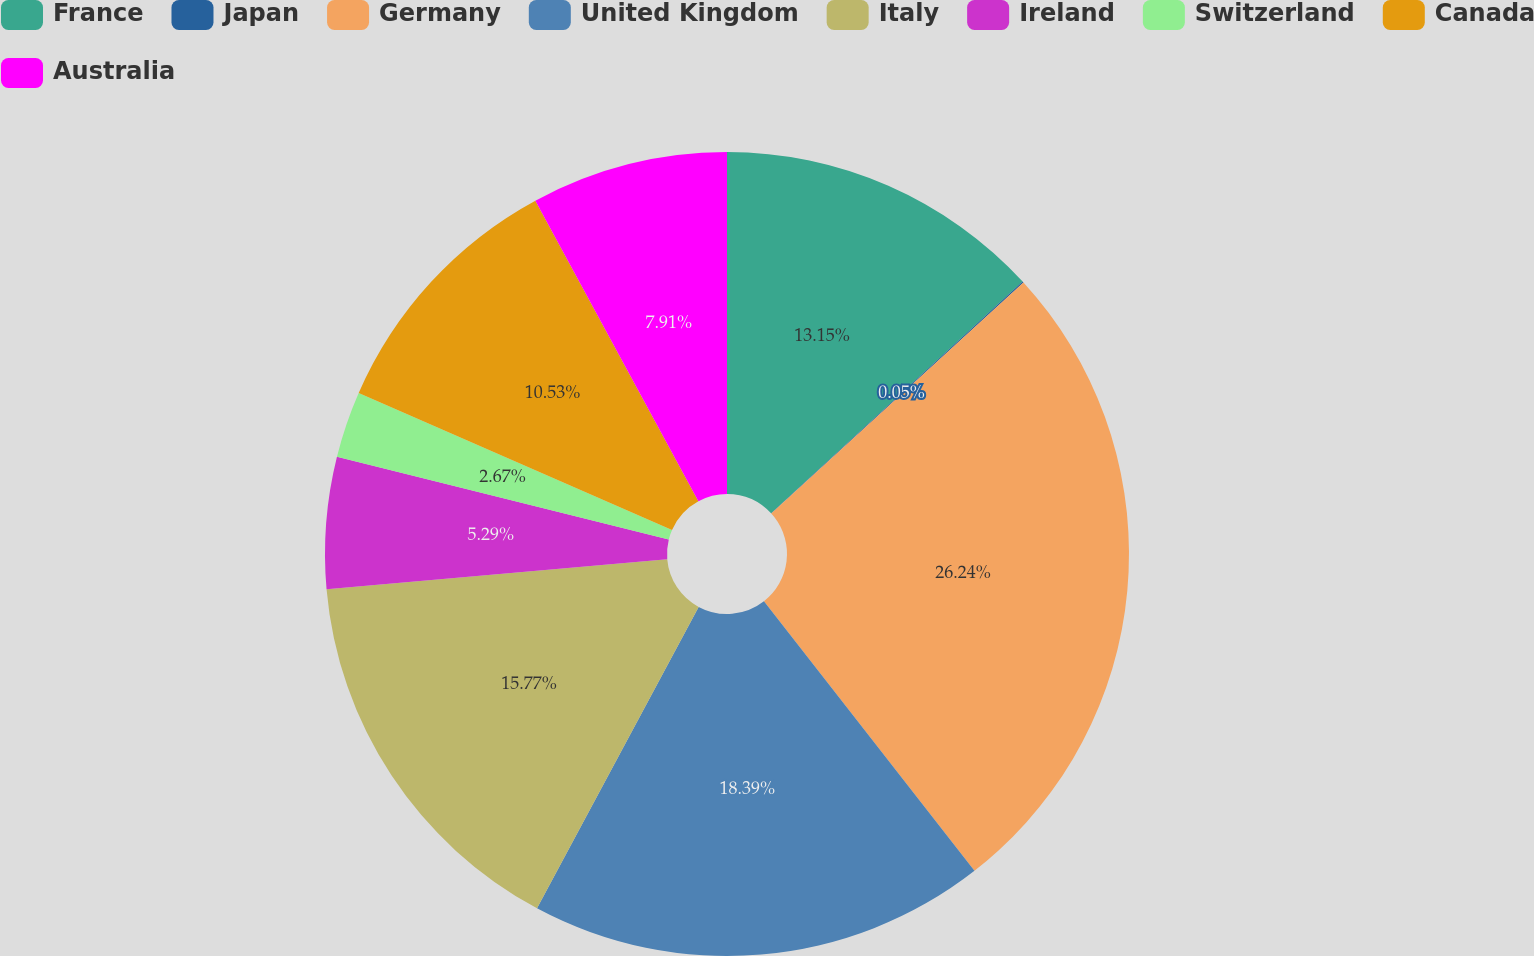<chart> <loc_0><loc_0><loc_500><loc_500><pie_chart><fcel>France<fcel>Japan<fcel>Germany<fcel>United Kingdom<fcel>Italy<fcel>Ireland<fcel>Switzerland<fcel>Canada<fcel>Australia<nl><fcel>13.15%<fcel>0.05%<fcel>26.25%<fcel>18.39%<fcel>15.77%<fcel>5.29%<fcel>2.67%<fcel>10.53%<fcel>7.91%<nl></chart> 